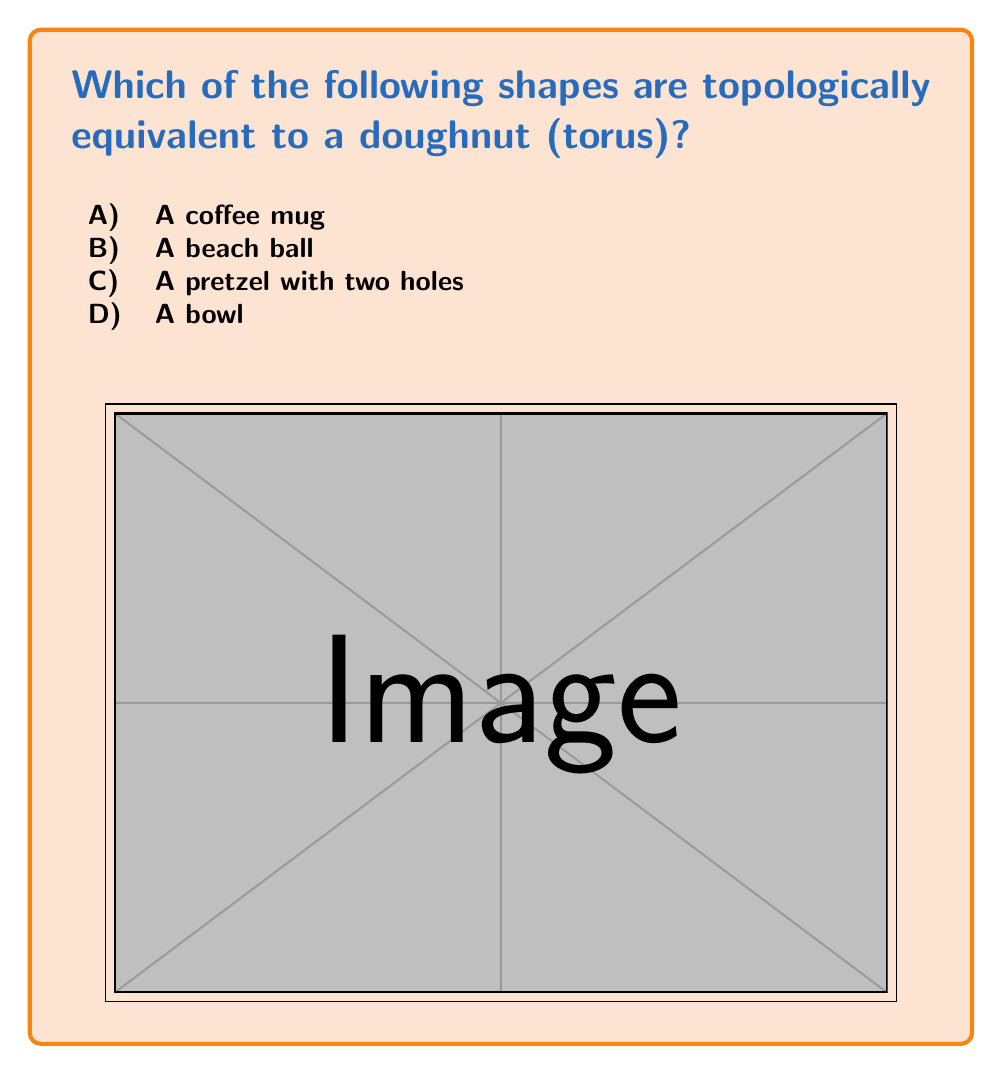Give your solution to this math problem. To understand topological equivalence, we need to think about shapes that can be transformed into each other without cutting or gluing. This concept is often explained to children as "reshaping playdough without breaking it apart or sticking pieces together."

Let's examine each option:

A) A coffee mug: A coffee mug is topologically equivalent to a doughnut (torus). The handle of the mug forms the hole of the doughnut, and the body of the mug can be continuously deformed to form the rest of the doughnut shape. This transformation doesn't require any cutting or gluing.

B) A beach ball: A beach ball is topologically equivalent to a sphere, which is different from a torus. A sphere has no holes, while a torus has one hole. We can't transform a beach ball into a doughnut shape without cutting it.

C) A pretzel with two holes: This shape has two holes, while a doughnut (torus) has only one hole. We can't remove one of the holes from the pretzel to make it equivalent to a torus without cutting it.

D) A bowl: A bowl is topologically equivalent to a sphere (like the beach ball). It doesn't have any holes that go all the way through it, unlike a doughnut.

To visualize this, imagine each shape made of soft clay:
- The coffee mug can be reshaped into a doughnut by pushing the body out and enlarging the handle.
- The beach ball and bowl can't form a doughnut shape without cutting a hole through them.
- The pretzel with two holes can't become a doughnut without filling in one of its holes.

Therefore, only the coffee mug is topologically equivalent to a doughnut (torus).
Answer: A) A coffee mug 